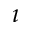<formula> <loc_0><loc_0><loc_500><loc_500>\imath</formula> 